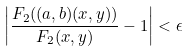<formula> <loc_0><loc_0><loc_500><loc_500>\left | \frac { F _ { 2 } ( ( a , b ) ( x , y ) ) } { F _ { 2 } ( x , y ) } - 1 \right | < \epsilon</formula> 